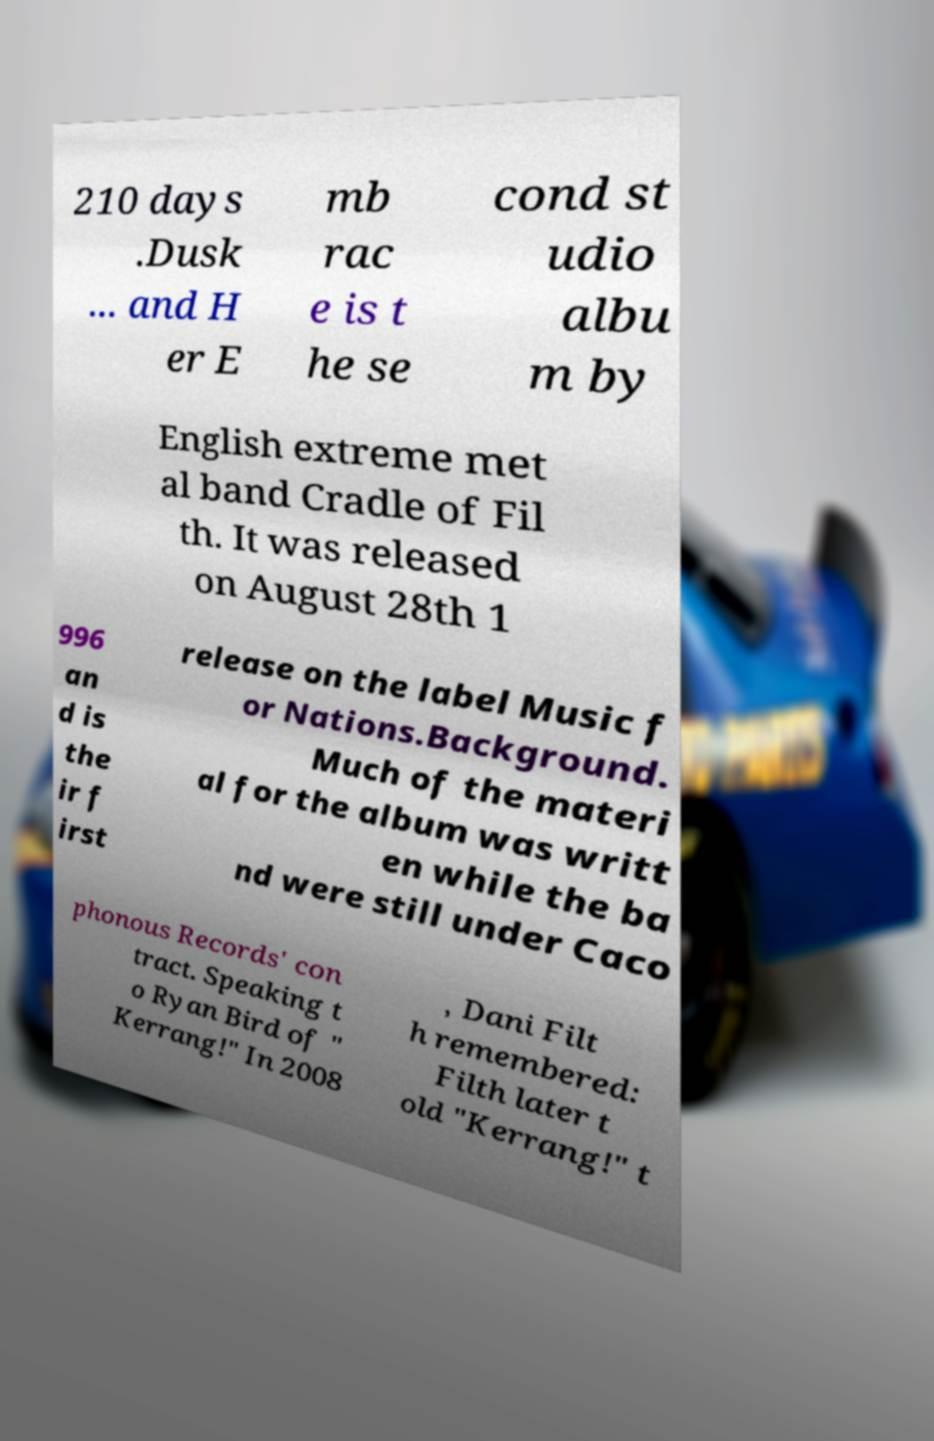Can you accurately transcribe the text from the provided image for me? 210 days .Dusk ... and H er E mb rac e is t he se cond st udio albu m by English extreme met al band Cradle of Fil th. It was released on August 28th 1 996 an d is the ir f irst release on the label Music f or Nations.Background. Much of the materi al for the album was writt en while the ba nd were still under Caco phonous Records' con tract. Speaking t o Ryan Bird of " Kerrang!" In 2008 , Dani Filt h remembered: Filth later t old "Kerrang!" t 